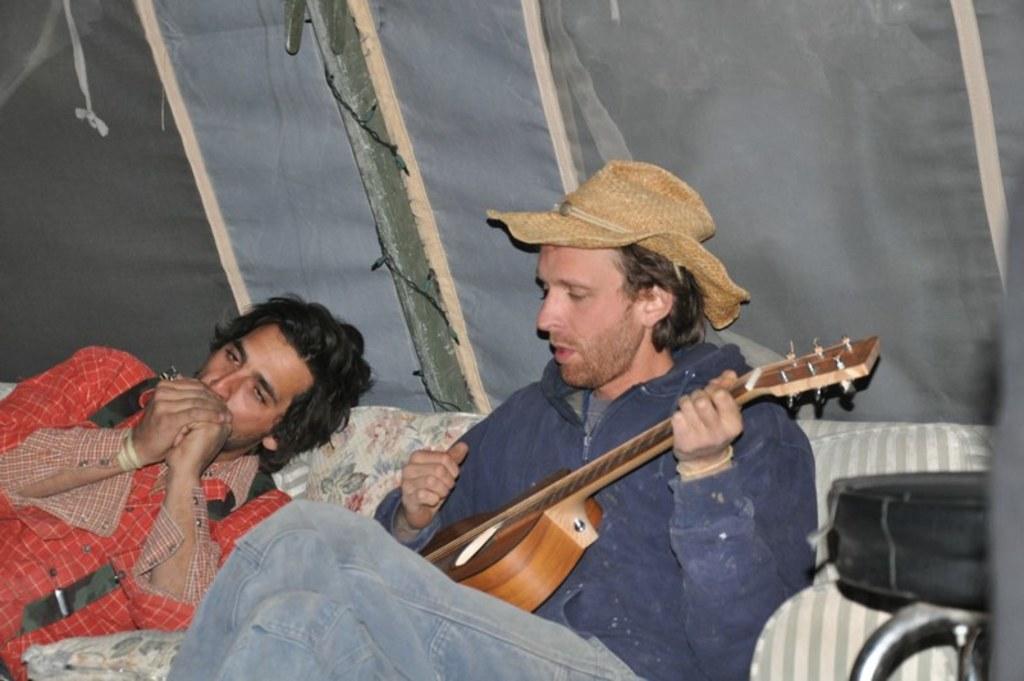How would you summarize this image in a sentence or two? In this image there are two persons who are playing musical instruments and at the right side of the image there is a person playing guitar and at the left side of the image there is a person playing musical instrument 